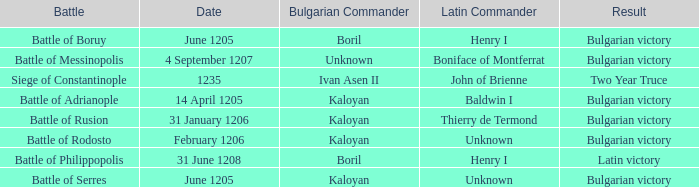On what Date was Henry I Latin Commander of the Battle of Boruy? June 1205. 